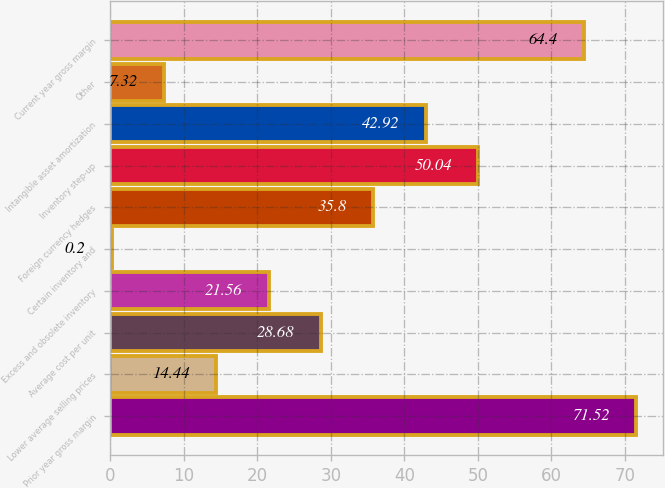Convert chart to OTSL. <chart><loc_0><loc_0><loc_500><loc_500><bar_chart><fcel>Prior year gross margin<fcel>Lower average selling prices<fcel>Average cost per unit<fcel>Excess and obsolete inventory<fcel>Certain inventory and<fcel>Foreign currency hedges<fcel>Inventory step-up<fcel>Intangible asset amortization<fcel>Other<fcel>Current year gross margin<nl><fcel>71.52<fcel>14.44<fcel>28.68<fcel>21.56<fcel>0.2<fcel>35.8<fcel>50.04<fcel>42.92<fcel>7.32<fcel>64.4<nl></chart> 